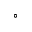<formula> <loc_0><loc_0><loc_500><loc_500>^ { \circ }</formula> 